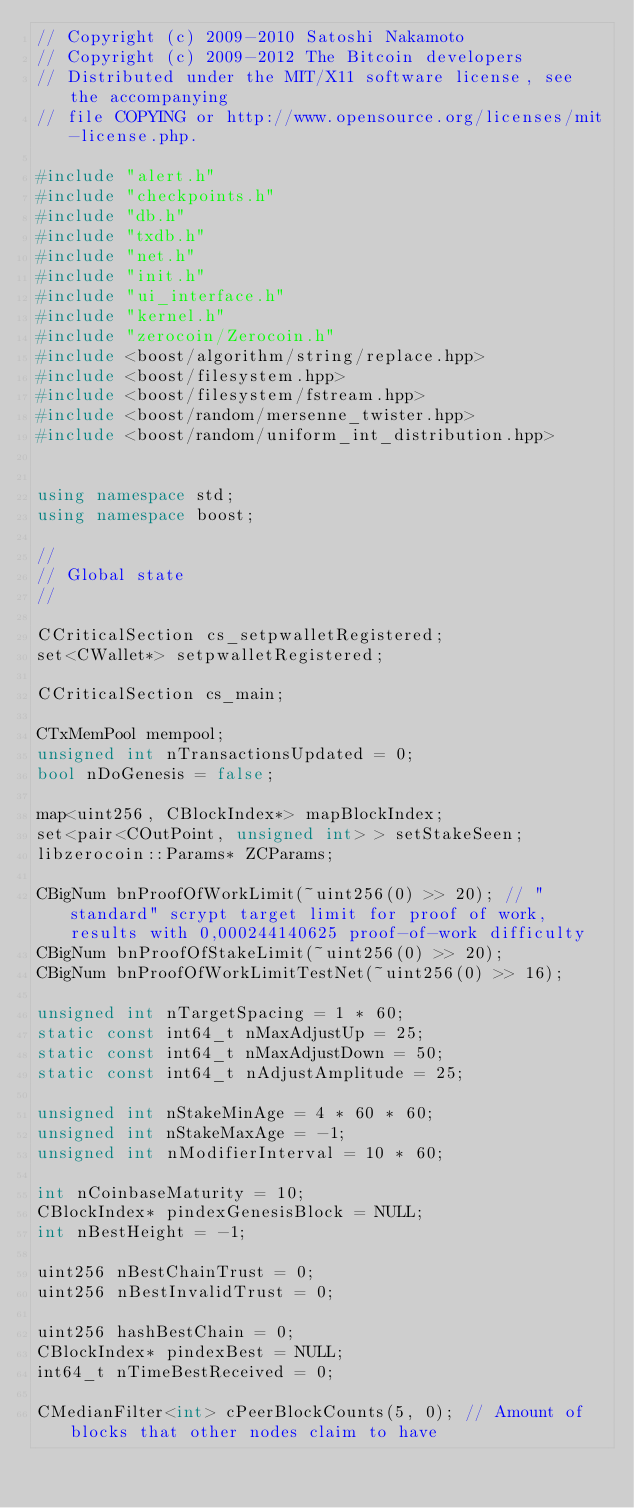<code> <loc_0><loc_0><loc_500><loc_500><_C++_>// Copyright (c) 2009-2010 Satoshi Nakamoto
// Copyright (c) 2009-2012 The Bitcoin developers
// Distributed under the MIT/X11 software license, see the accompanying
// file COPYING or http://www.opensource.org/licenses/mit-license.php.

#include "alert.h"
#include "checkpoints.h"
#include "db.h"
#include "txdb.h"
#include "net.h"
#include "init.h"
#include "ui_interface.h"
#include "kernel.h"
#include "zerocoin/Zerocoin.h"
#include <boost/algorithm/string/replace.hpp>
#include <boost/filesystem.hpp>
#include <boost/filesystem/fstream.hpp>
#include <boost/random/mersenne_twister.hpp>
#include <boost/random/uniform_int_distribution.hpp>


using namespace std;
using namespace boost;

//
// Global state
//

CCriticalSection cs_setpwalletRegistered;
set<CWallet*> setpwalletRegistered;

CCriticalSection cs_main;

CTxMemPool mempool;
unsigned int nTransactionsUpdated = 0;
bool nDoGenesis = false;

map<uint256, CBlockIndex*> mapBlockIndex;
set<pair<COutPoint, unsigned int> > setStakeSeen;
libzerocoin::Params* ZCParams;

CBigNum bnProofOfWorkLimit(~uint256(0) >> 20); // "standard" scrypt target limit for proof of work, results with 0,000244140625 proof-of-work difficulty
CBigNum bnProofOfStakeLimit(~uint256(0) >> 20);
CBigNum bnProofOfWorkLimitTestNet(~uint256(0) >> 16);

unsigned int nTargetSpacing = 1 * 60;
static const int64_t nMaxAdjustUp = 25;
static const int64_t nMaxAdjustDown = 50;
static const int64_t nAdjustAmplitude = 25;

unsigned int nStakeMinAge = 4 * 60 * 60;
unsigned int nStakeMaxAge = -1;
unsigned int nModifierInterval = 10 * 60;

int nCoinbaseMaturity = 10;
CBlockIndex* pindexGenesisBlock = NULL;
int nBestHeight = -1;

uint256 nBestChainTrust = 0;
uint256 nBestInvalidTrust = 0;

uint256 hashBestChain = 0;
CBlockIndex* pindexBest = NULL;
int64_t nTimeBestReceived = 0;

CMedianFilter<int> cPeerBlockCounts(5, 0); // Amount of blocks that other nodes claim to have
</code> 